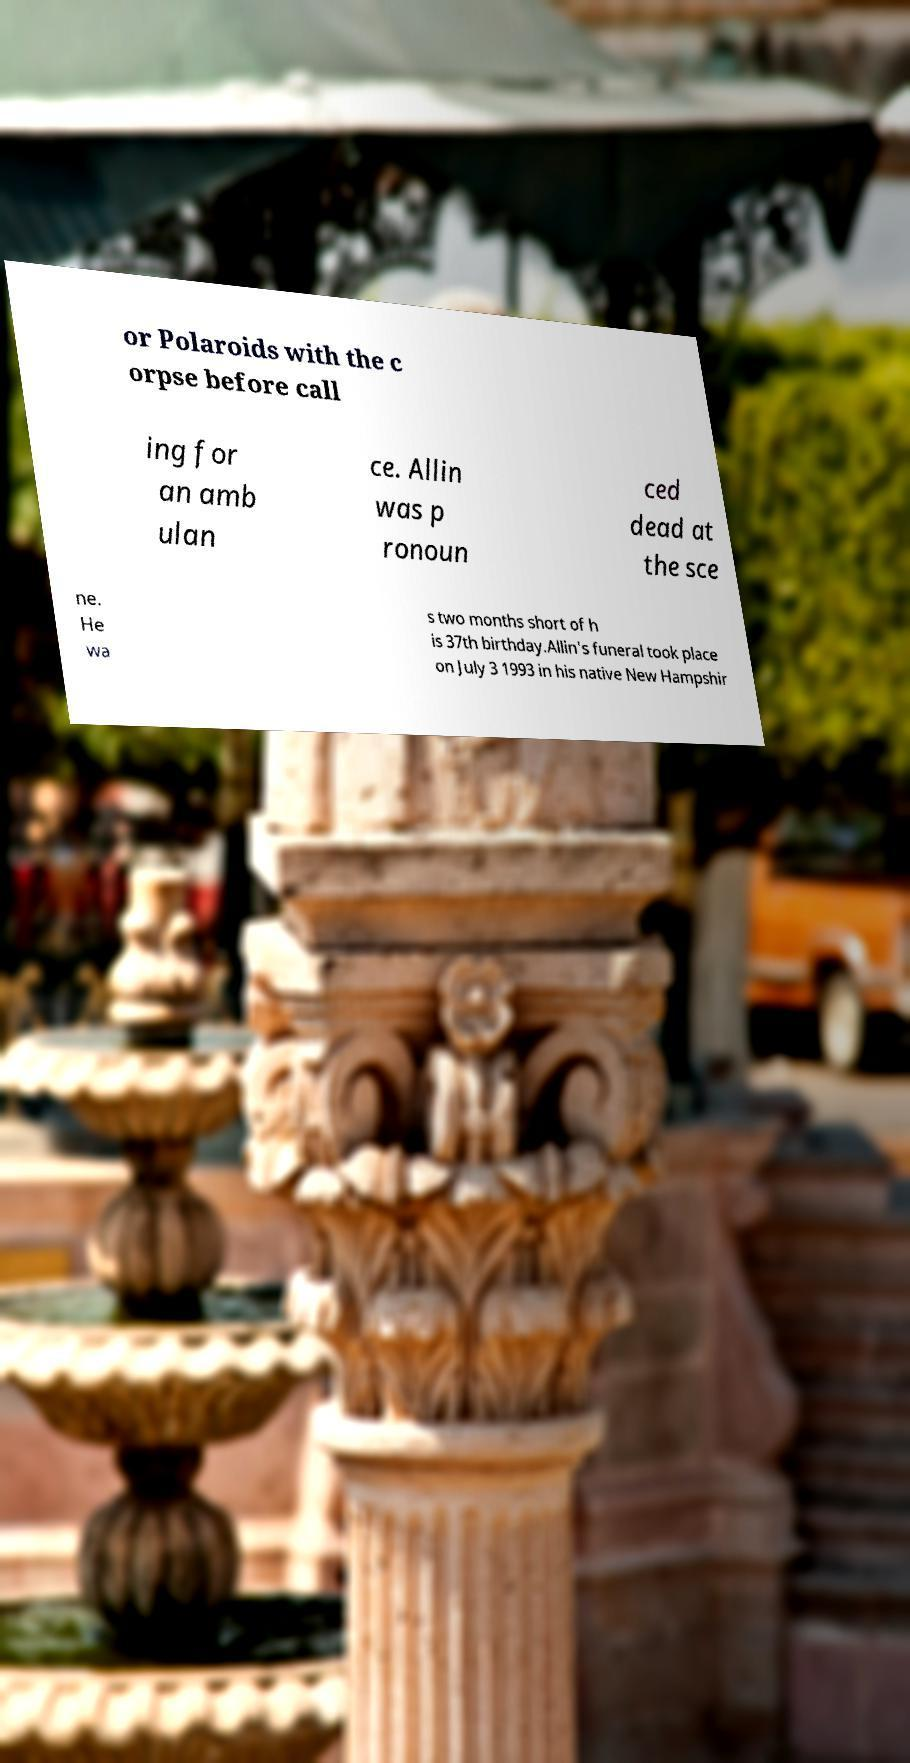There's text embedded in this image that I need extracted. Can you transcribe it verbatim? or Polaroids with the c orpse before call ing for an amb ulan ce. Allin was p ronoun ced dead at the sce ne. He wa s two months short of h is 37th birthday.Allin's funeral took place on July 3 1993 in his native New Hampshir 